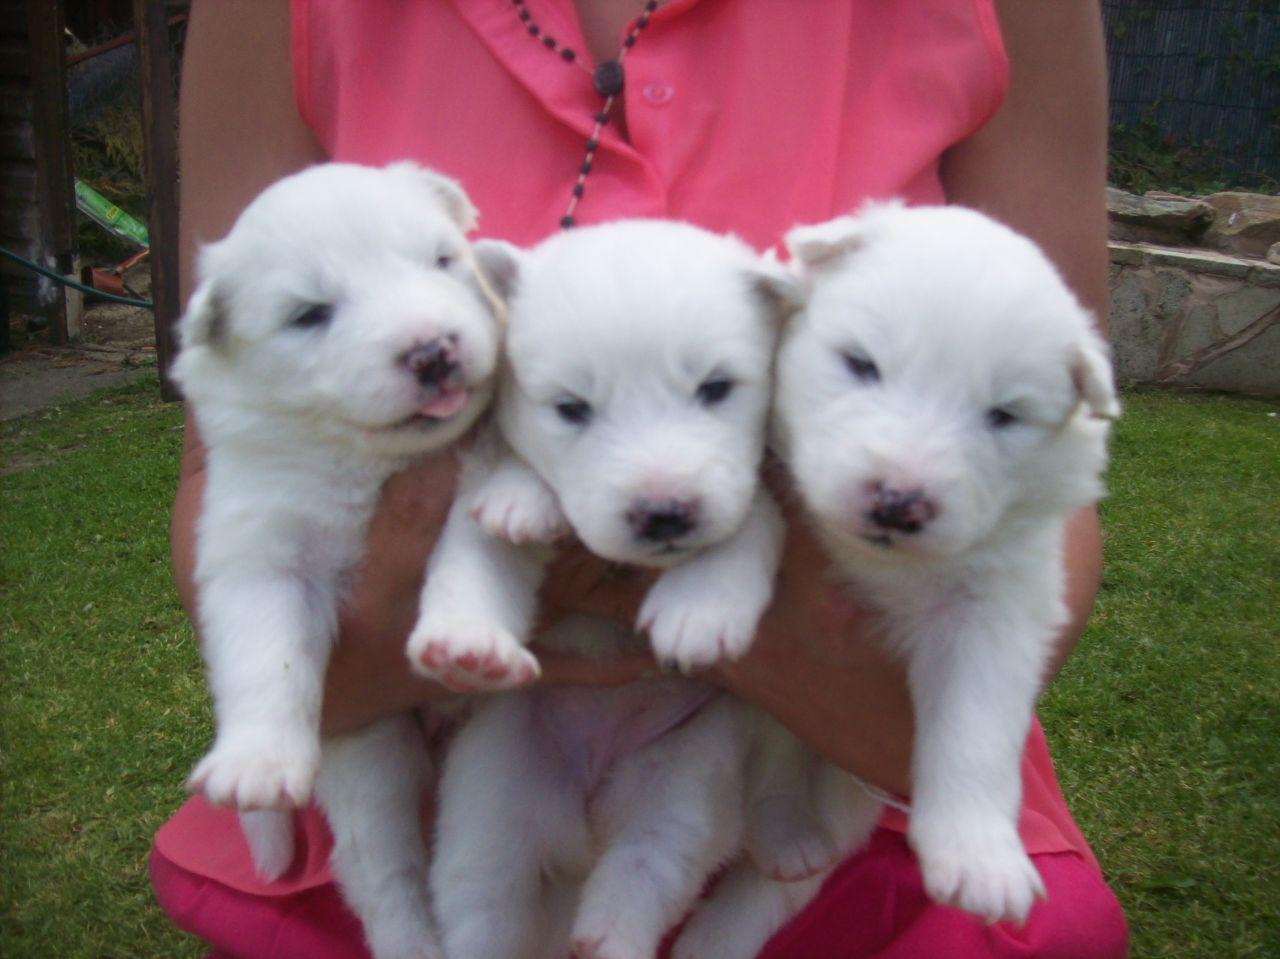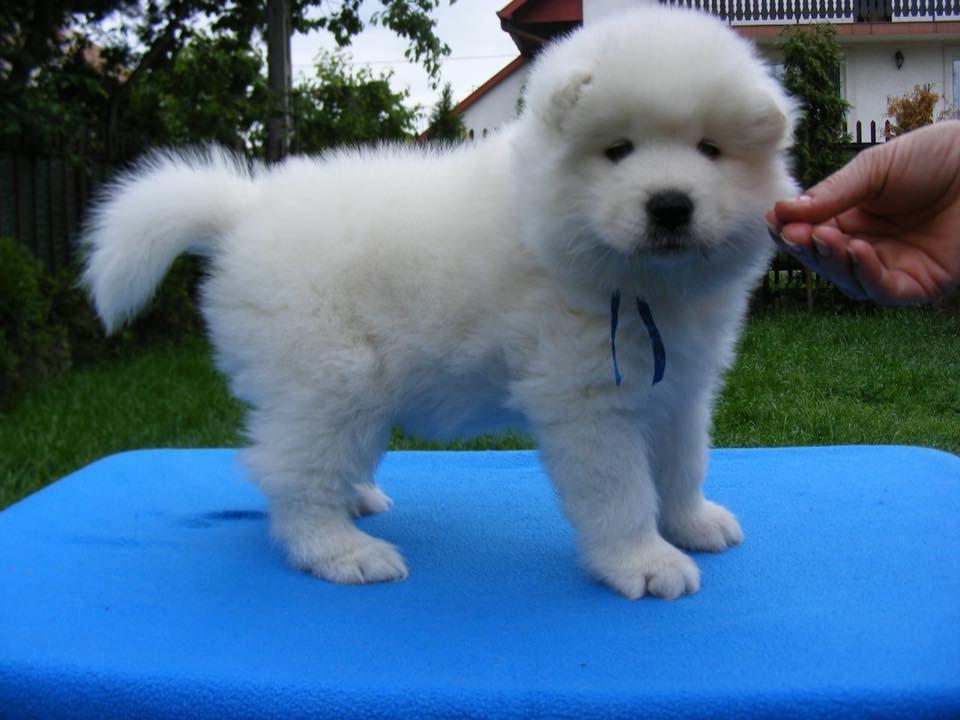The first image is the image on the left, the second image is the image on the right. Examine the images to the left and right. Is the description "There is no more than one white dog in the right image." accurate? Answer yes or no. Yes. The first image is the image on the left, the second image is the image on the right. Evaluate the accuracy of this statement regarding the images: "Hands are holding up at least five white puppies in one image.". Is it true? Answer yes or no. No. 